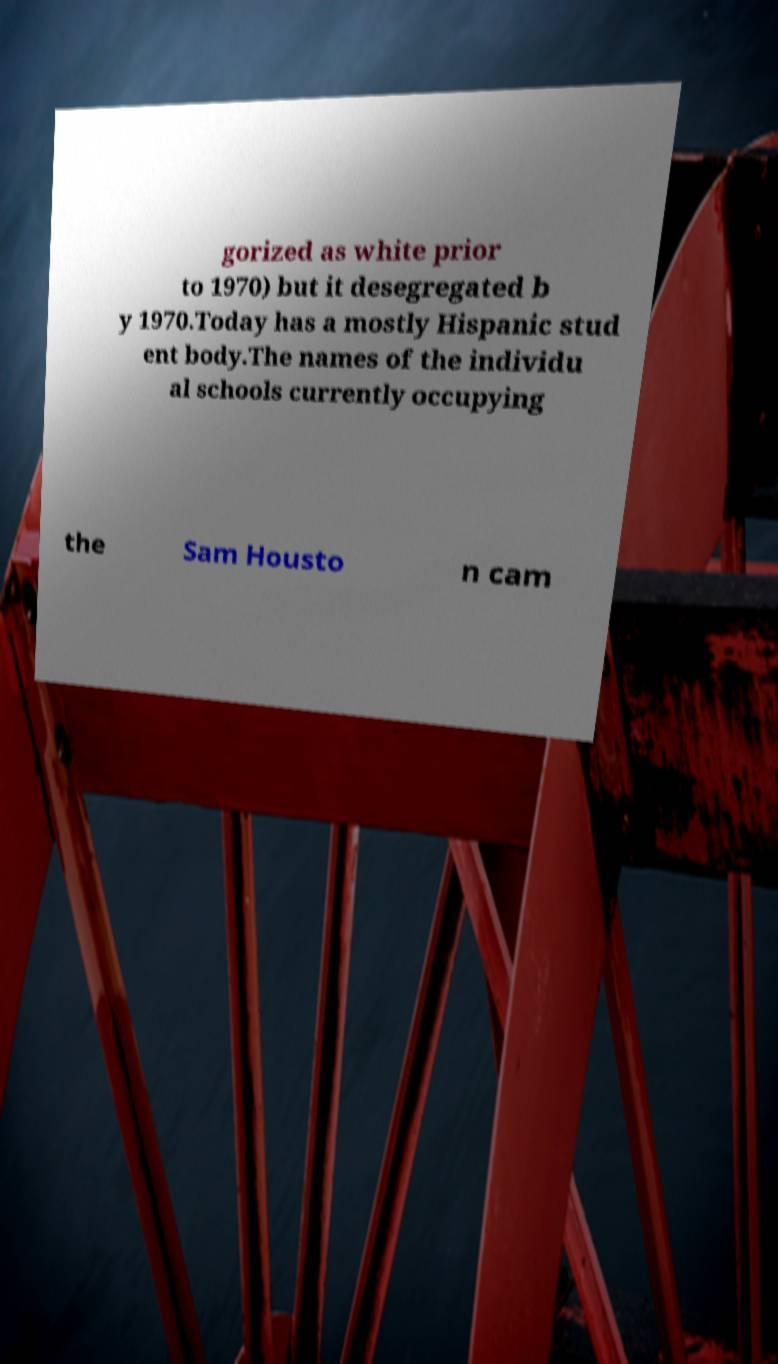Could you assist in decoding the text presented in this image and type it out clearly? gorized as white prior to 1970) but it desegregated b y 1970.Today has a mostly Hispanic stud ent body.The names of the individu al schools currently occupying the Sam Housto n cam 